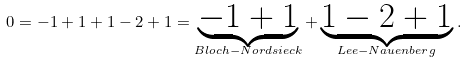Convert formula to latex. <formula><loc_0><loc_0><loc_500><loc_500>0 = - 1 + 1 + 1 - 2 + 1 = \underbrace { - 1 + 1 } _ { B l o c h - N o r d s i e c k } + \underbrace { 1 - 2 + 1 } _ { L e e - N a u e n b e r g } \, .</formula> 